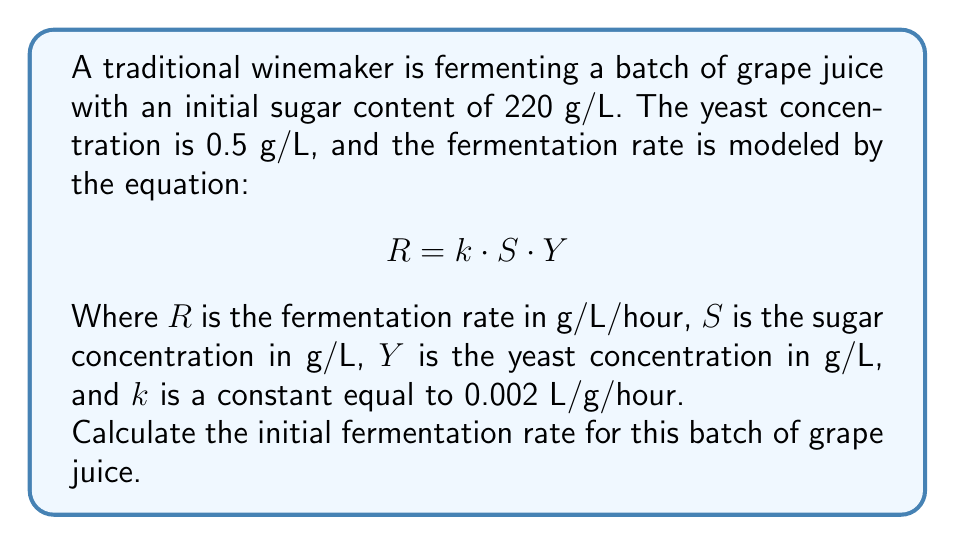Teach me how to tackle this problem. To solve this problem, we'll follow these steps:

1. Identify the given values:
   - Initial sugar content ($S$) = 220 g/L
   - Yeast concentration ($Y$) = 0.5 g/L
   - Constant ($k$) = 0.002 L/g/hour

2. Use the given equation:
   $$R = k \cdot S \cdot Y$$

3. Substitute the values into the equation:
   $$R = 0.002 \text{ L/g/hour} \cdot 220 \text{ g/L} \cdot 0.5 \text{ g/L}$$

4. Perform the calculation:
   $$R = 0.002 \cdot 220 \cdot 0.5 = 0.22 \text{ g/L/hour}$$

The initial fermentation rate is 0.22 g/L/hour, which means that in the beginning, 0.22 grams of sugar per liter of grape juice will be consumed by the yeast each hour.
Answer: 0.22 g/L/hour 